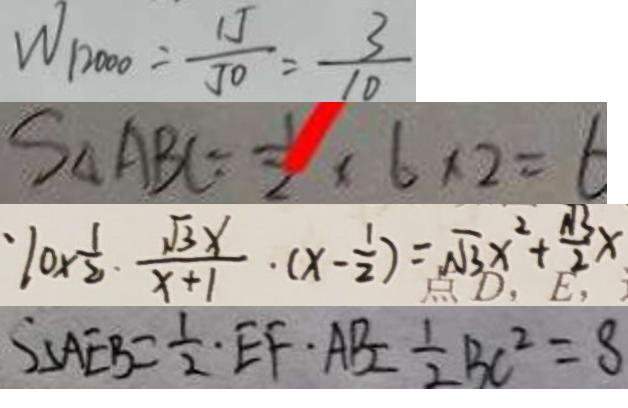<formula> <loc_0><loc_0><loc_500><loc_500>W _ { 1 2 0 0 0 } = \frac { 1 J } { J 0 } = \frac { 3 } { 1 0 } 
 S _ { \Delta A B C } = \frac { 1 } { 2 } \times 6 \times 2 = 6 
 1 0 \times \frac { 1 } { 2 } \cdot \frac { \sqrt { 3 } x } { x + 1 } \cdot ( x - \frac { 1 } { 2 } ) = \sqrt { 3 } x ^ { 2 } + \frac { \sqrt { 3 } } { 2 } x 
 S _ { \Delta A E B } = \frac { 1 } { 2 } E F \cdot A B = \frac { 1 } { 2 } B C ^ { 2 } = 8</formula> 